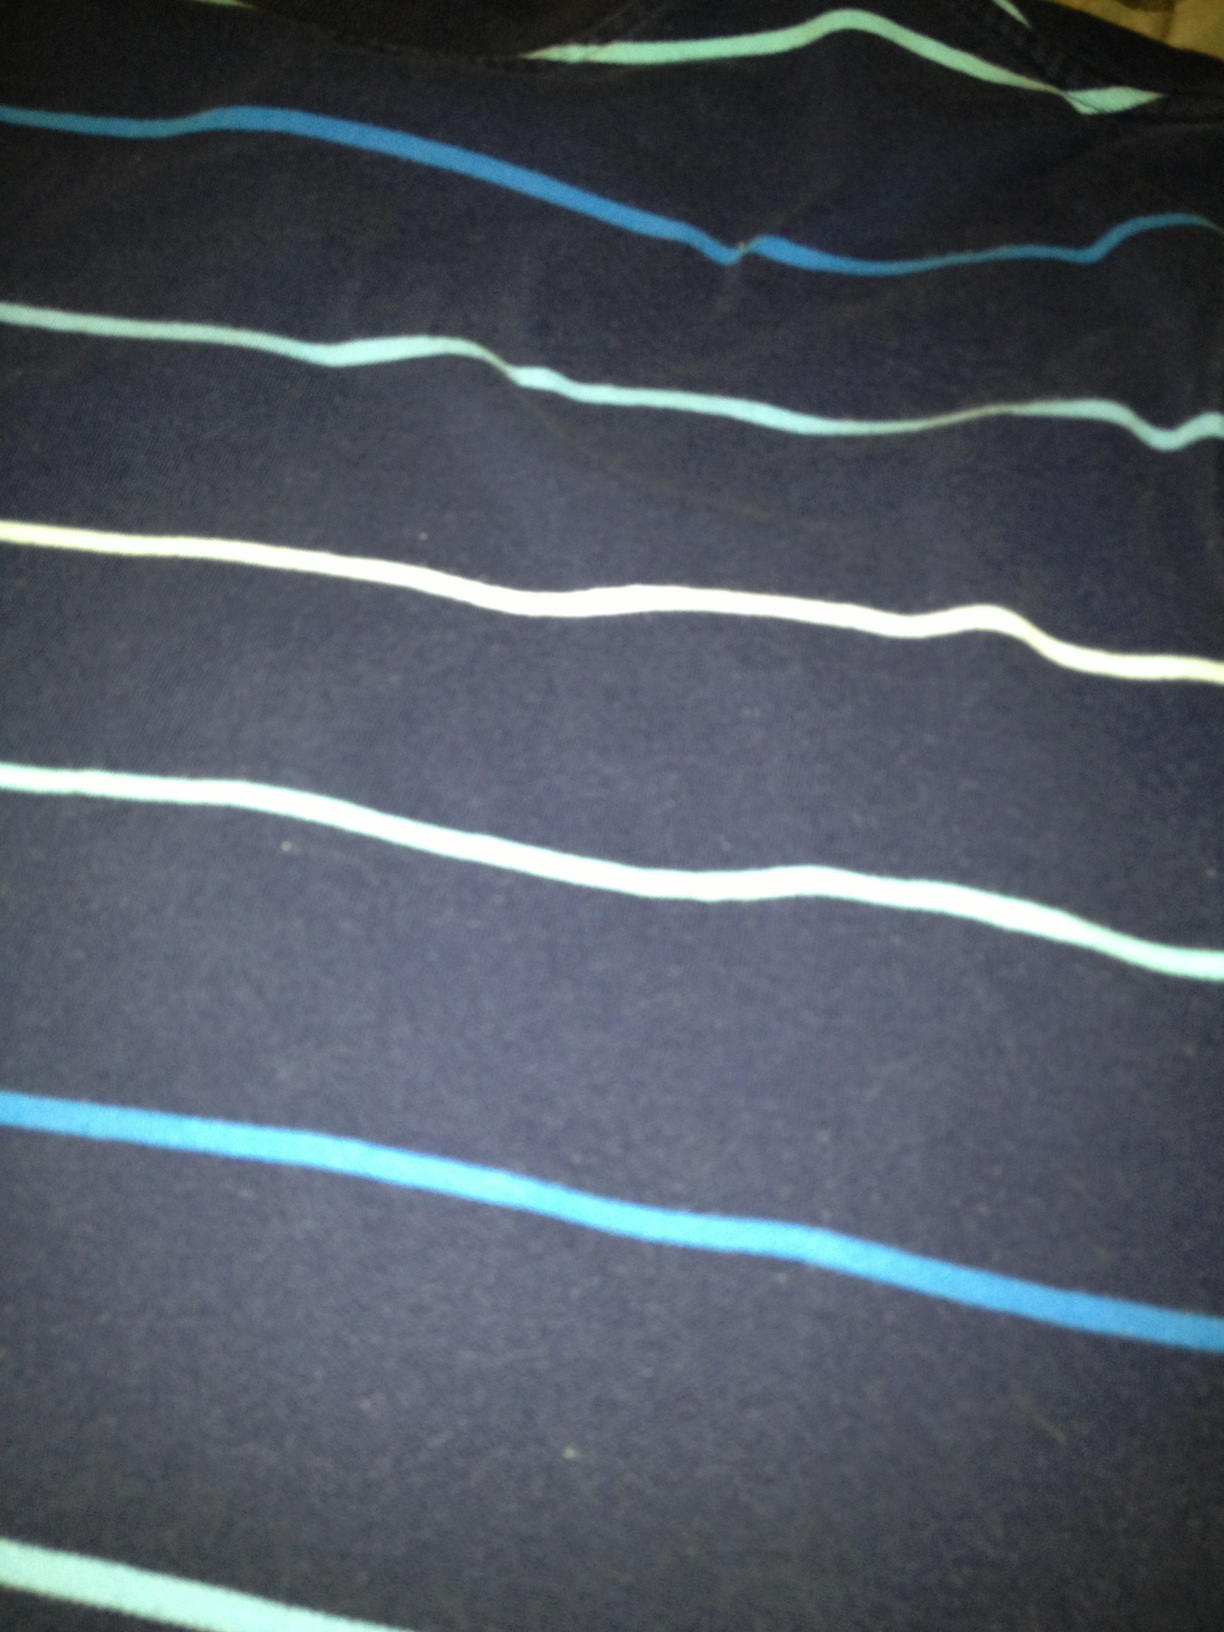What does the fabric of this shirt look like it feels like? The fabric of the shirt appears to be soft and comfortable, likely made from a cotton blend. It looks breathable and ideal for casual wear, providing a comfortable fit without being too restrictive. What accessories would go well with this shirt? To enhance the look of this casual shirt, you could add a stylish watch with a leather strap, a simple bracelet, or a pair of cool sunglasses. A casual cap or hat could also complement the outfit perfectly, especially for a day out in the sun. Imagine the shirt could talk. What would it say about its experiences? If this shirt could talk, it might share tales of relaxed beach outings, lazy afternoons in the park, and spontaneous road trips with friends. It would recall moments of joy, comfort, and laughter, serving as a witness to many cherished memories. It might also express its excitement for the next adventure, always ready to be part of fun and memorable experiences. Create a short story inspired by the shirt’s pattern. Once upon a time in a small coastal village, there was an artisan named Leo who took great pride in his craft. Leo loved the sea, and it inspired his creations. One day, while gazing at the horizon, he had an idea – to weave the essence of the sea into a fabric. He carefully chose shades of blue and white, the colors of the waves and the foam, and wove them into a dark grey fabric representing the deep ocean. This fabric became a shirt that radiated the calm and beauty of the sea. Anyone who wore it felt a sense of peace and connection to the ocean, carrying with them its stories and mysteries wherever they went. The shirt became a cherished possession, passed down through generations, each thread holding memories of seaside adventures and serene moments by the shore. 